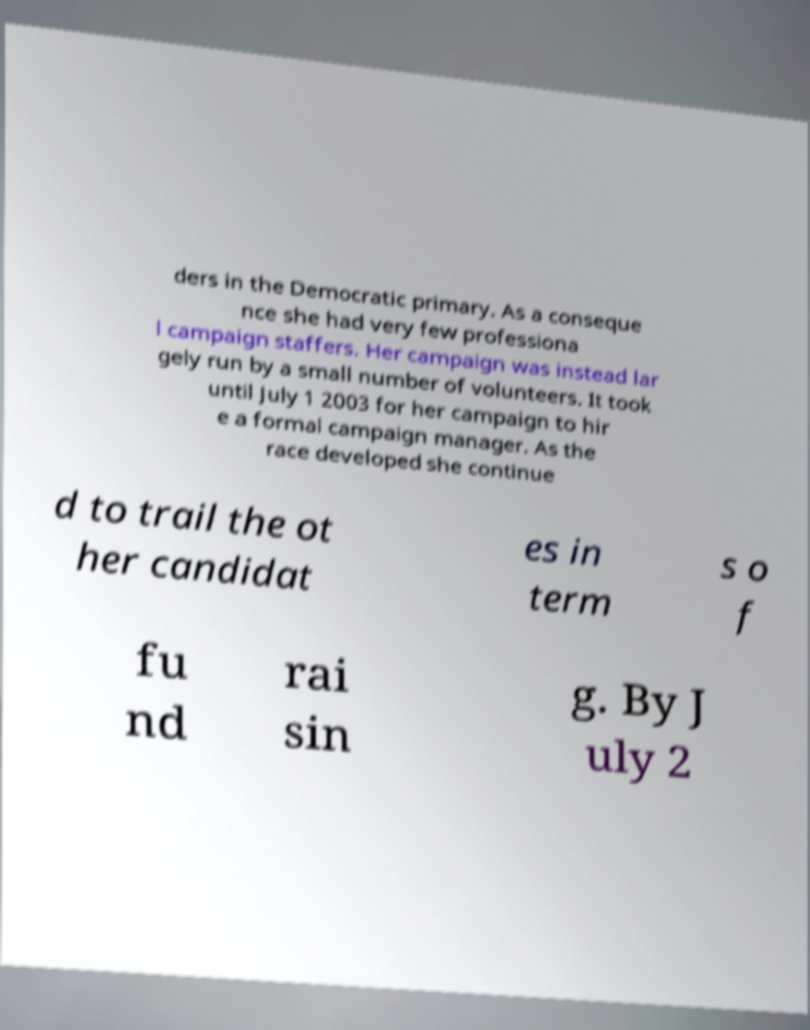Could you extract and type out the text from this image? ders in the Democratic primary. As a conseque nce she had very few professiona l campaign staffers. Her campaign was instead lar gely run by a small number of volunteers. It took until July 1 2003 for her campaign to hir e a formal campaign manager. As the race developed she continue d to trail the ot her candidat es in term s o f fu nd rai sin g. By J uly 2 